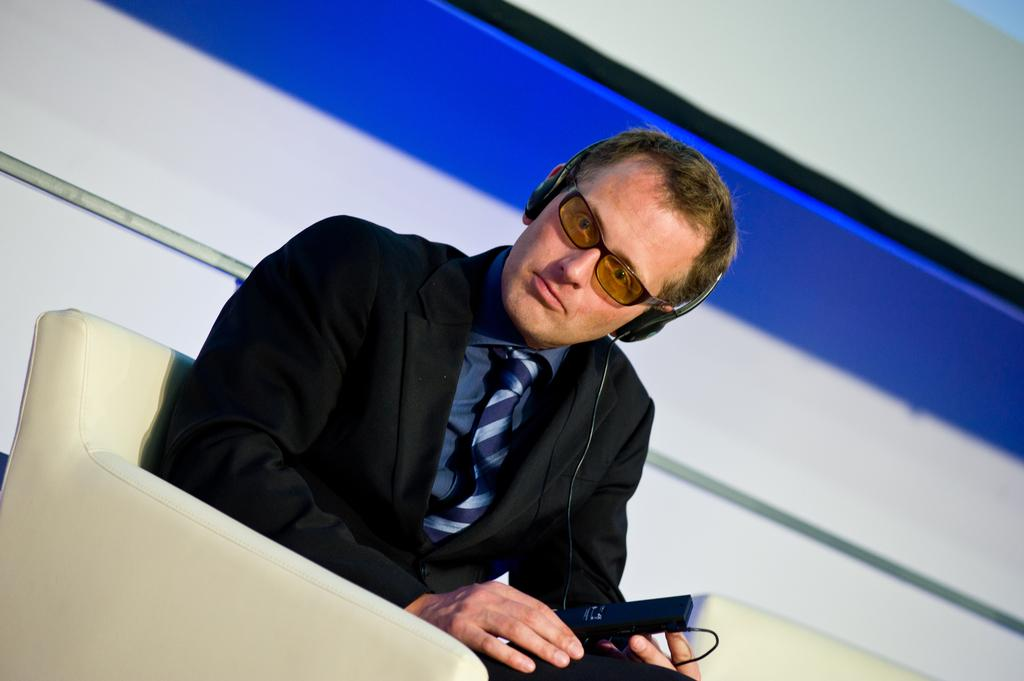What is the main subject of the image? There is a person in the image. What is the person wearing? The person is wearing goggles. Where is the person sitting? The person is sitting on a sofa. What can be seen near the person's ears? There are headphones visible in the image. What is the person holding? The person is holding a black color object. What is visible in the background of the image? There is a wall in the background of the image. Can you tell me how many wings the animal has in the image? There is no animal present in the image, and therefore no wings can be observed. 